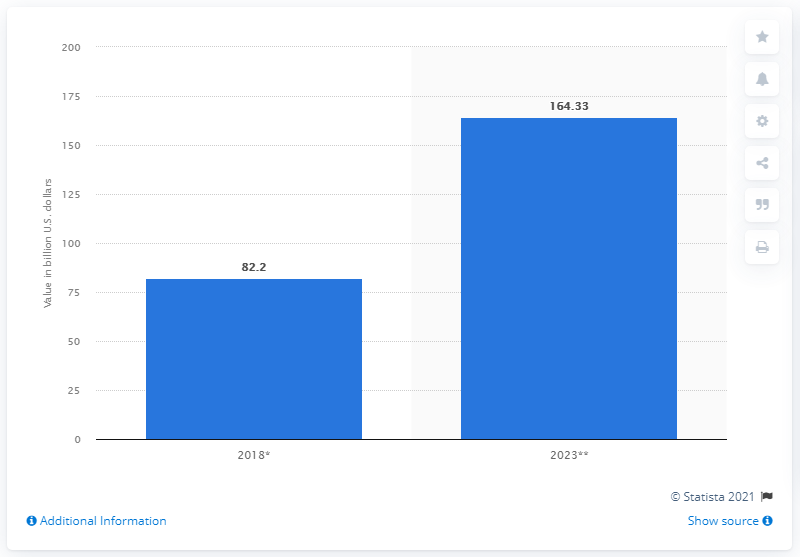Indicate a few pertinent items in this graphic. According to estimates, the processed meat market was valued at approximately 82.2 billion dollars in 2018. The estimated value of the processed meat market in Latin America by 2023 is projected to be $164.33 million. 